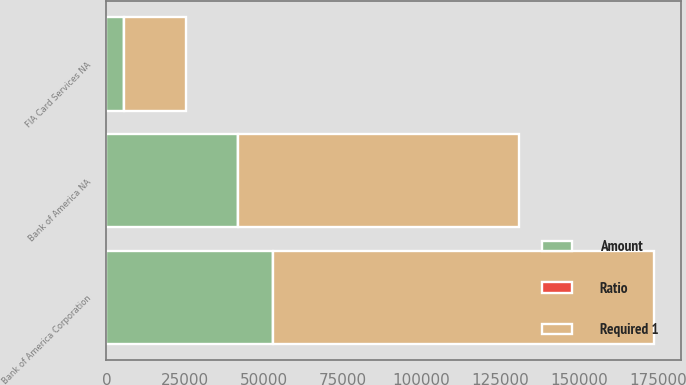Convert chart. <chart><loc_0><loc_0><loc_500><loc_500><stacked_bar_chart><ecel><fcel>Bank of America Corporation<fcel>Bank of America NA<fcel>FIA Card Services NA<nl><fcel>Ratio<fcel>9.15<fcel>8.51<fcel>13.9<nl><fcel>Required 1<fcel>120814<fcel>88979<fcel>19573<nl><fcel>Amount<fcel>52833<fcel>41818<fcel>5632<nl></chart> 